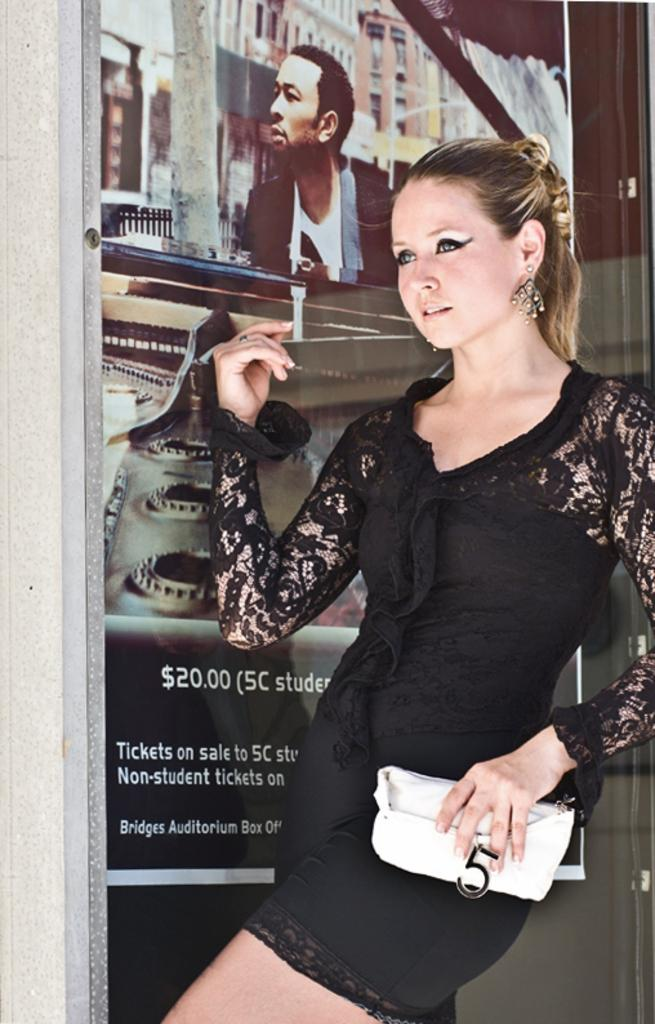Who is present in the image? There is a woman in the image. What is the woman doing in the image? The woman is standing in the image. What is the woman holding in the image? The woman is holding a bag in the image. What can be seen in the background of the image? There are posts on a glass in the background of the image. What type of pancake is the woman flipping in the image? There is no pancake present in the image, and the woman is not flipping anything. 